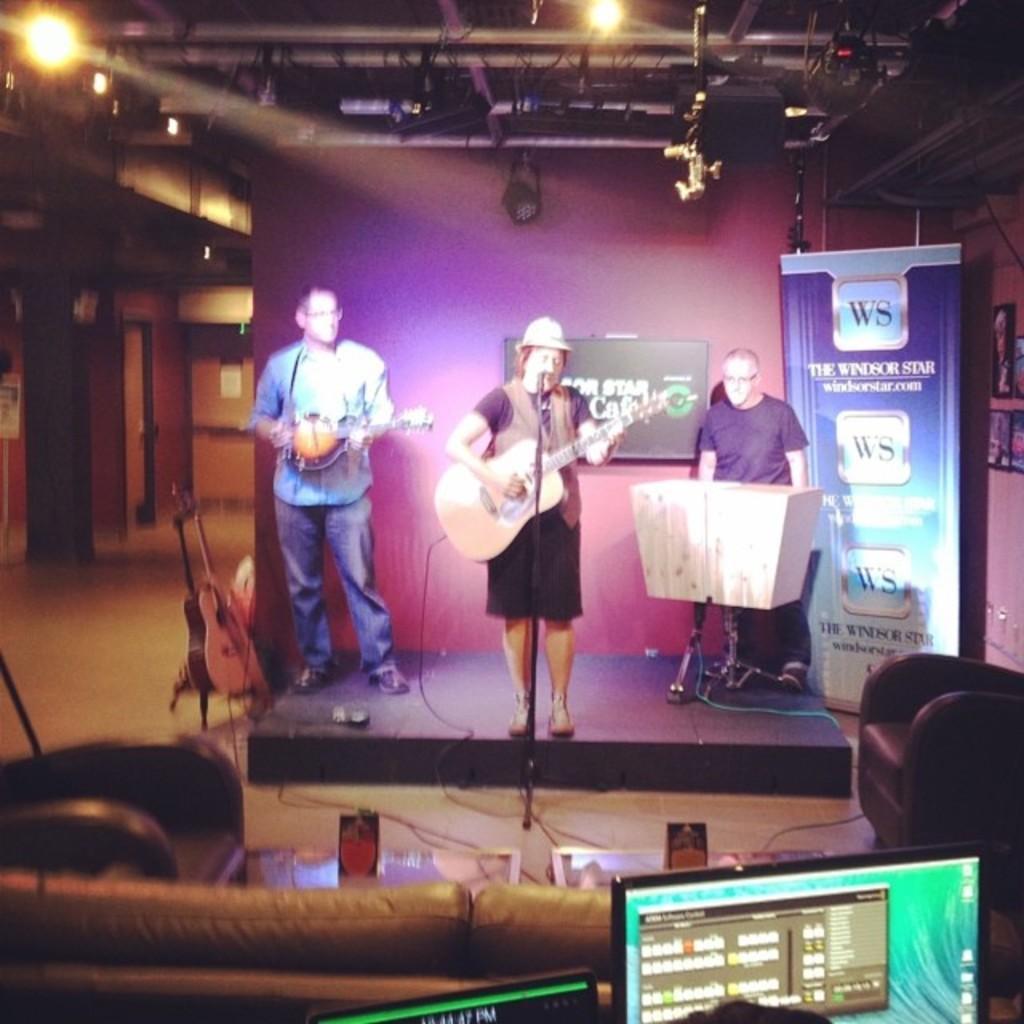Please provide a concise description of this image. In this image I can see 3 people on the stage among them these two people are holding musical instruments in hands. Here I can see a microphone and some other objects. OIn the right side I can see a banner and photos on the wall. Here I can see a monitor, chairs and other objects. I can also see lights on the ceiling. 